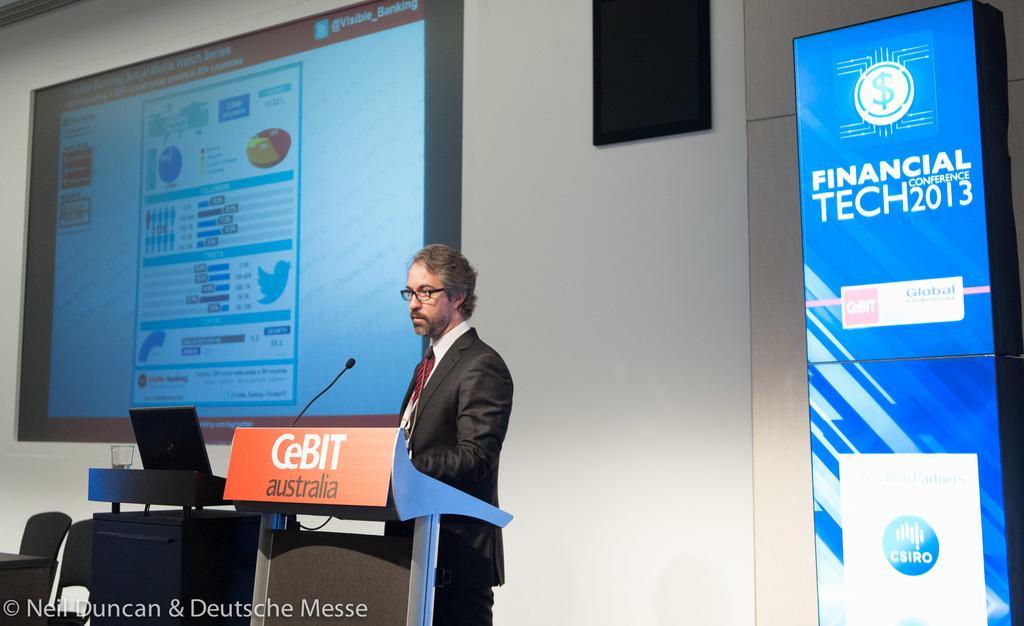In one or two sentences, can you explain what this image depicts? In this image, we can see a man in a suit is standing near the podium. Here we can see banner, chairs, table, desk, laptop, glass and microphone. Background we can see wall, screen and black color object. On the left side bottom corner, we can see watermark in the image. 